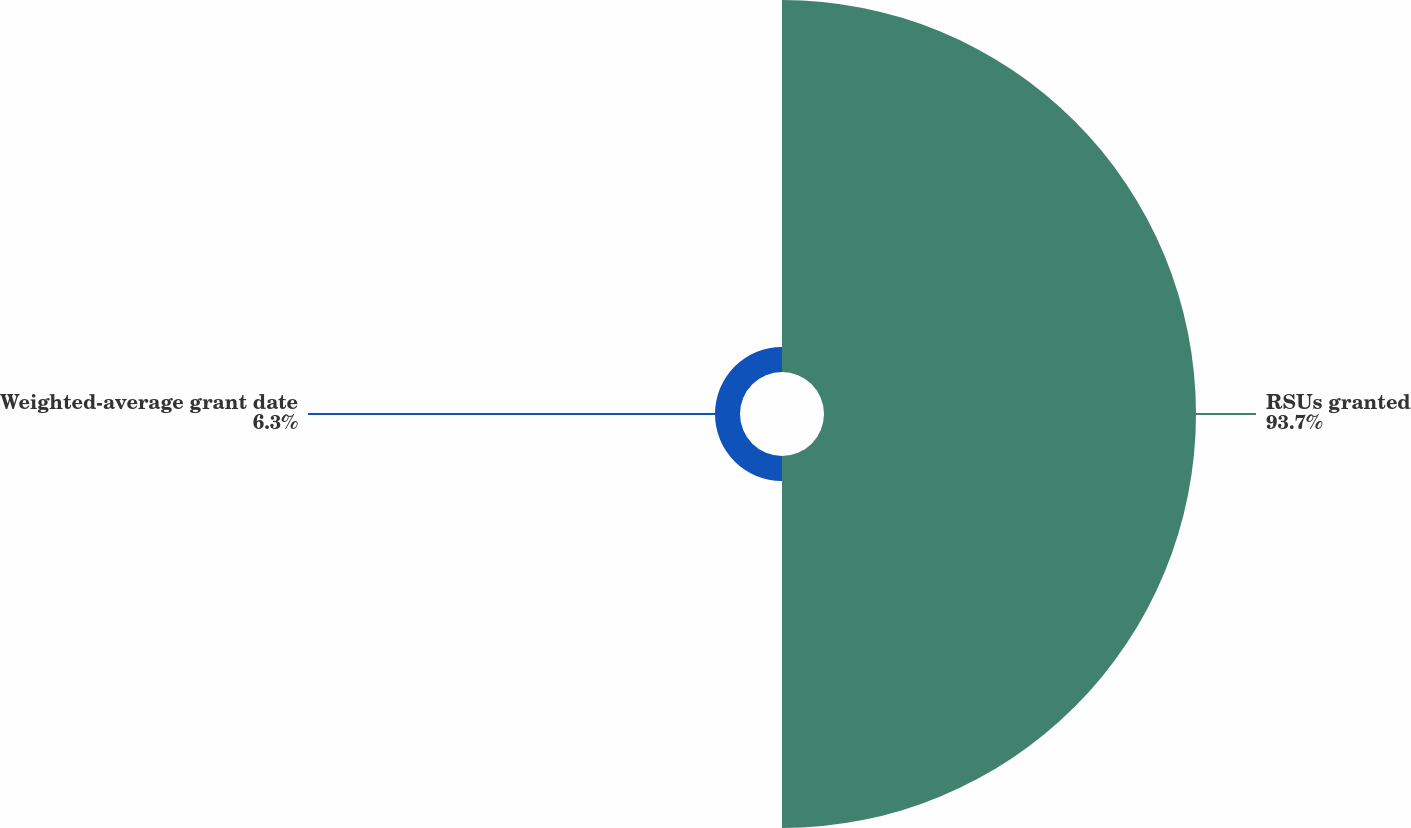Convert chart. <chart><loc_0><loc_0><loc_500><loc_500><pie_chart><fcel>RSUs granted<fcel>Weighted-average grant date<nl><fcel>93.7%<fcel>6.3%<nl></chart> 